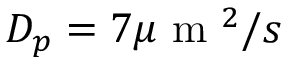<formula> <loc_0><loc_0><loc_500><loc_500>D _ { p } = 7 \mu m ^ { 2 } / s</formula> 